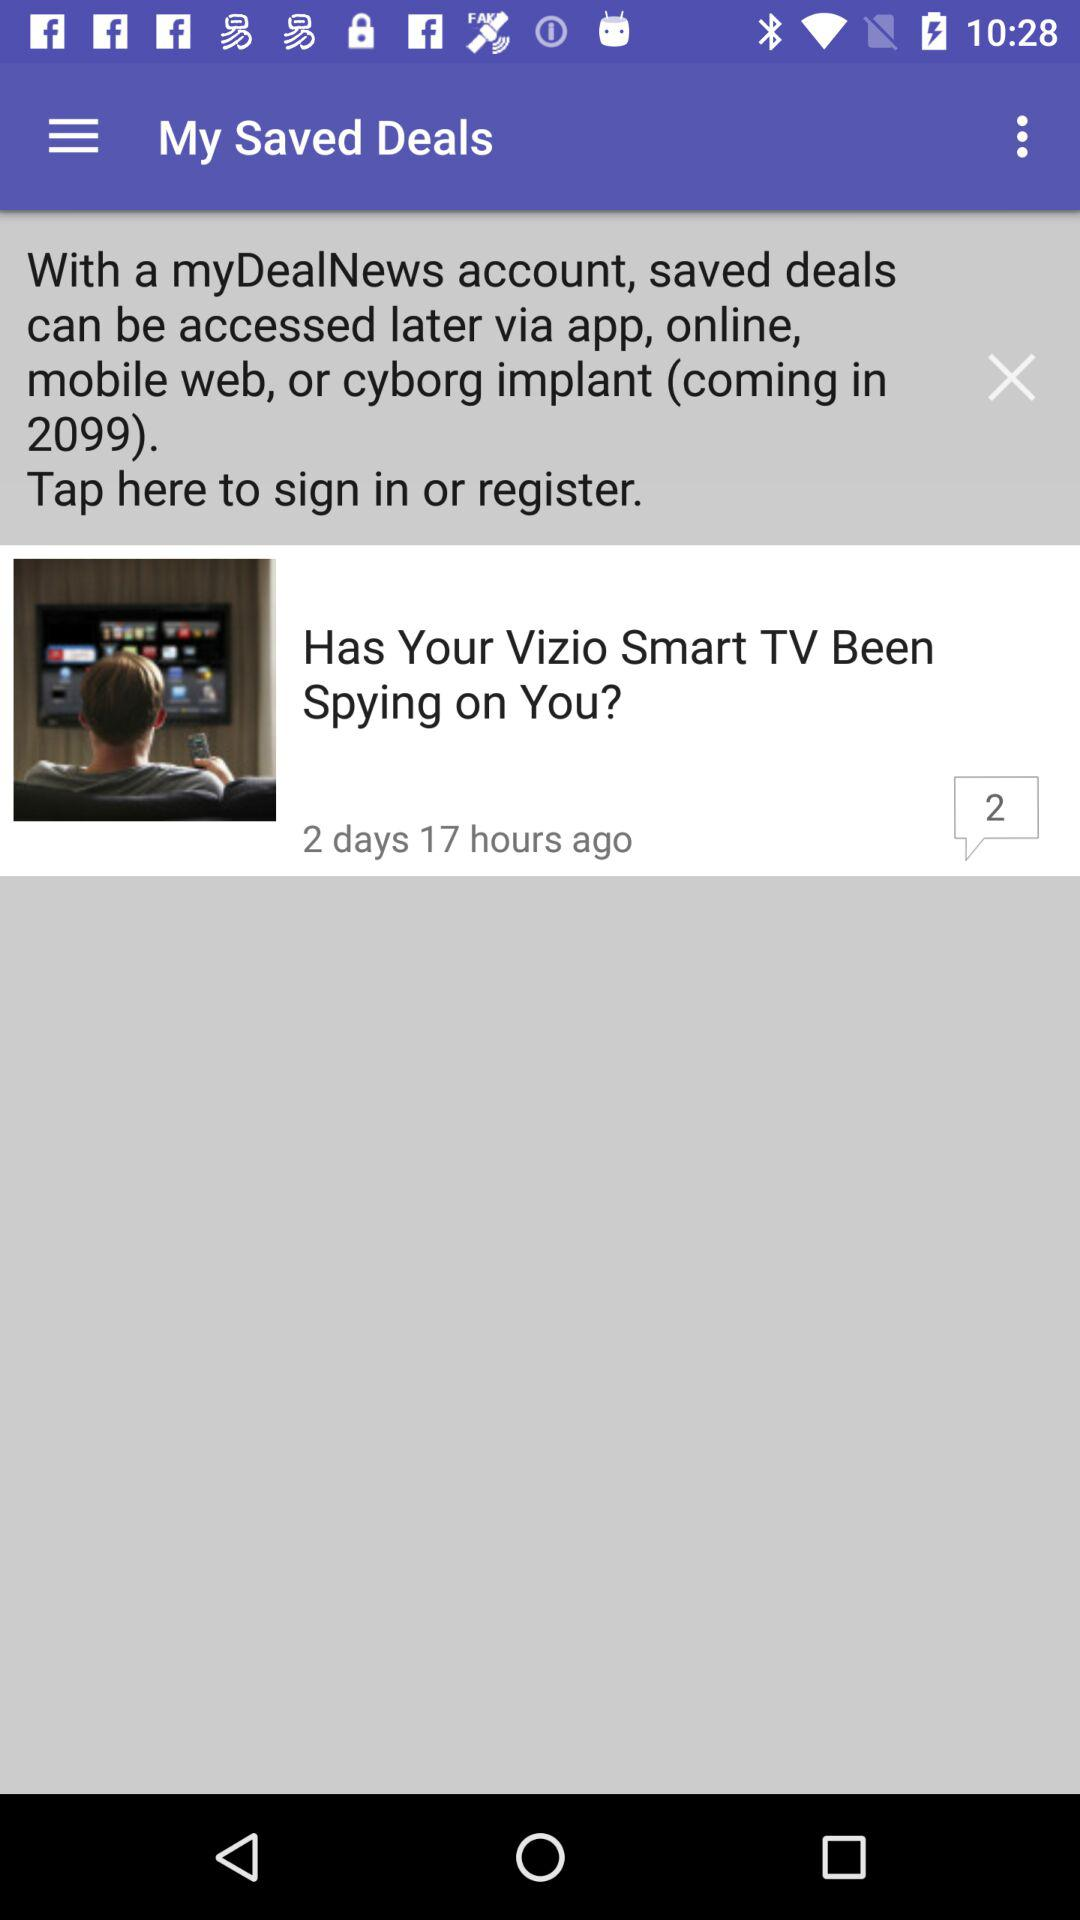In which year did deals come to an end?
When the provided information is insufficient, respond with <no answer>. <no answer> 